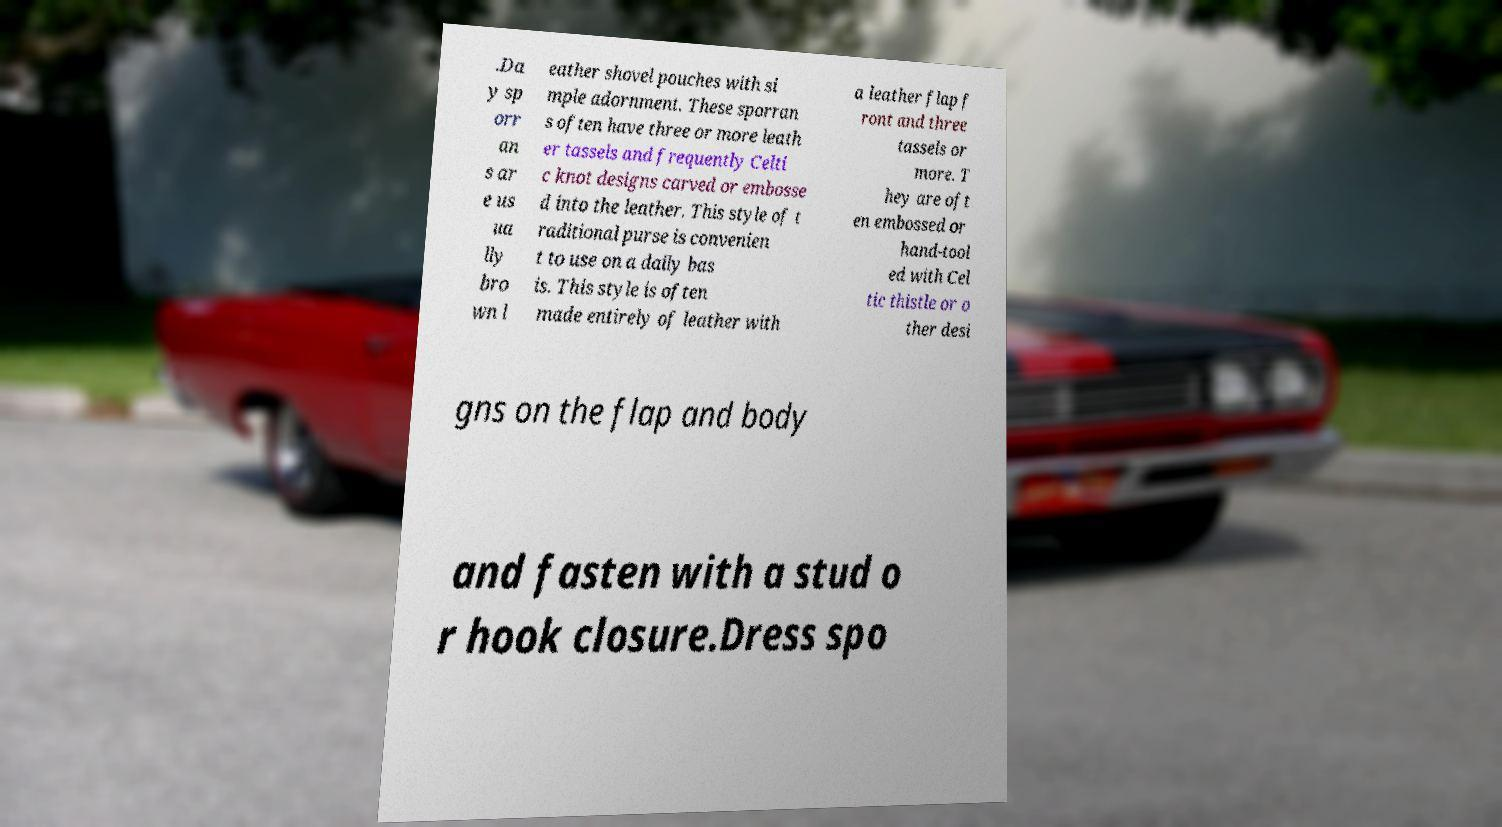What messages or text are displayed in this image? I need them in a readable, typed format. .Da y sp orr an s ar e us ua lly bro wn l eather shovel pouches with si mple adornment. These sporran s often have three or more leath er tassels and frequently Celti c knot designs carved or embosse d into the leather. This style of t raditional purse is convenien t to use on a daily bas is. This style is often made entirely of leather with a leather flap f ront and three tassels or more. T hey are oft en embossed or hand-tool ed with Cel tic thistle or o ther desi gns on the flap and body and fasten with a stud o r hook closure.Dress spo 